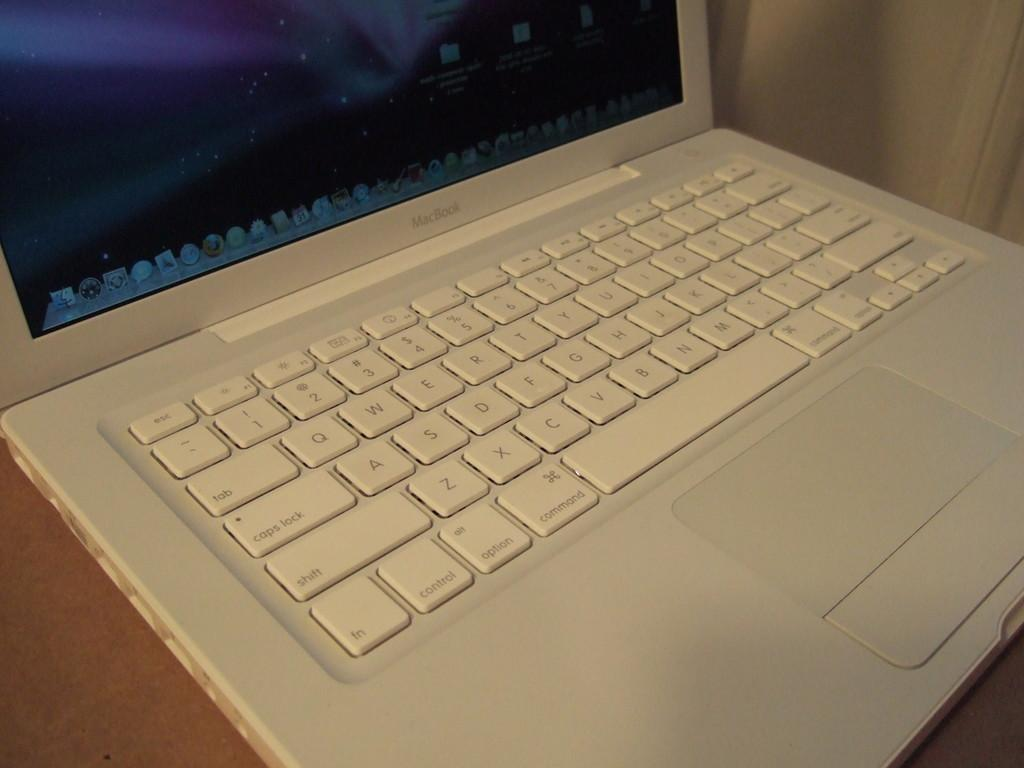<image>
Describe the image concisely. White Macbook with purple wallpaper on a wooden table. 